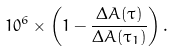Convert formula to latex. <formula><loc_0><loc_0><loc_500><loc_500>1 0 ^ { 6 } \times \left ( 1 - \frac { \Delta A ( \tau ) } { \Delta A ( \tau _ { 1 } ) } \right ) .</formula> 